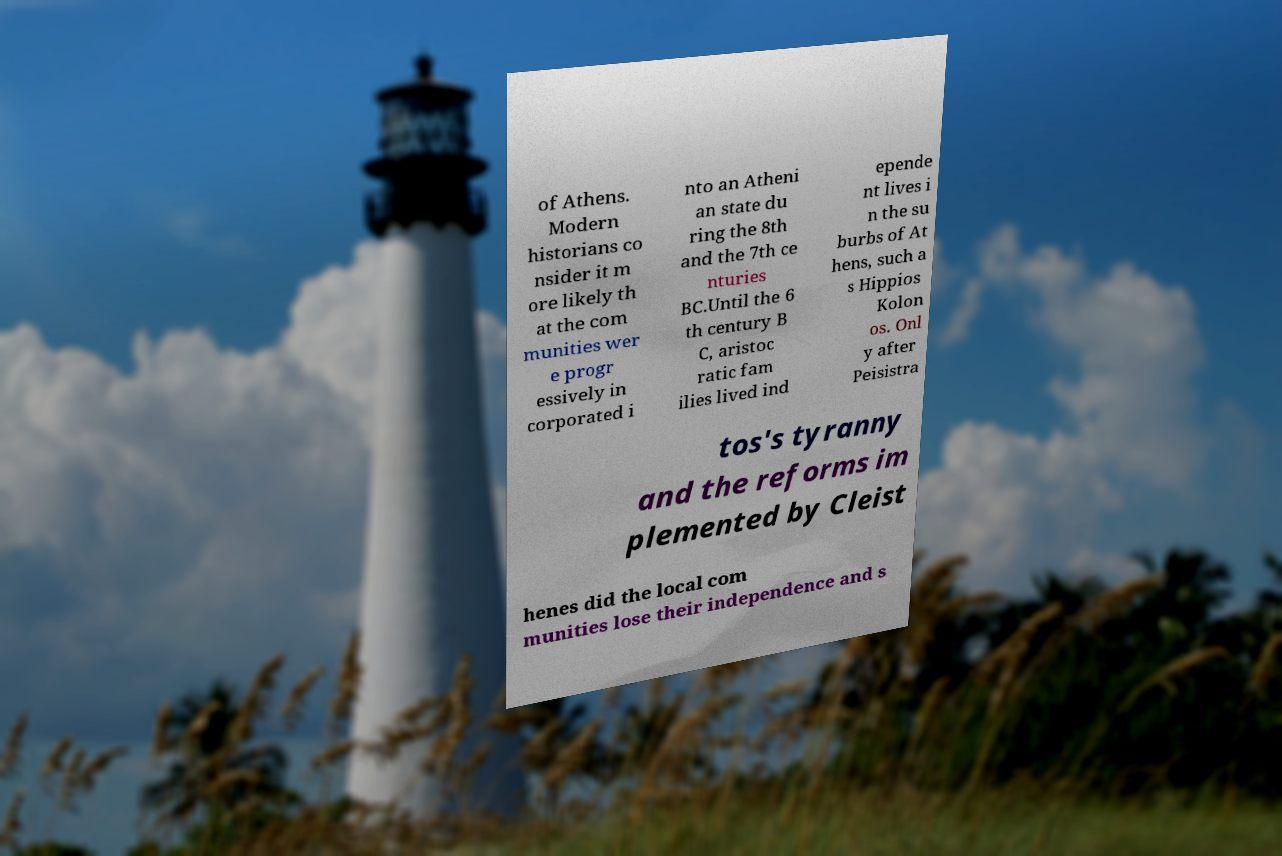Can you read and provide the text displayed in the image?This photo seems to have some interesting text. Can you extract and type it out for me? of Athens. Modern historians co nsider it m ore likely th at the com munities wer e progr essively in corporated i nto an Atheni an state du ring the 8th and the 7th ce nturies BC.Until the 6 th century B C, aristoc ratic fam ilies lived ind epende nt lives i n the su burbs of At hens, such a s Hippios Kolon os. Onl y after Peisistra tos's tyranny and the reforms im plemented by Cleist henes did the local com munities lose their independence and s 